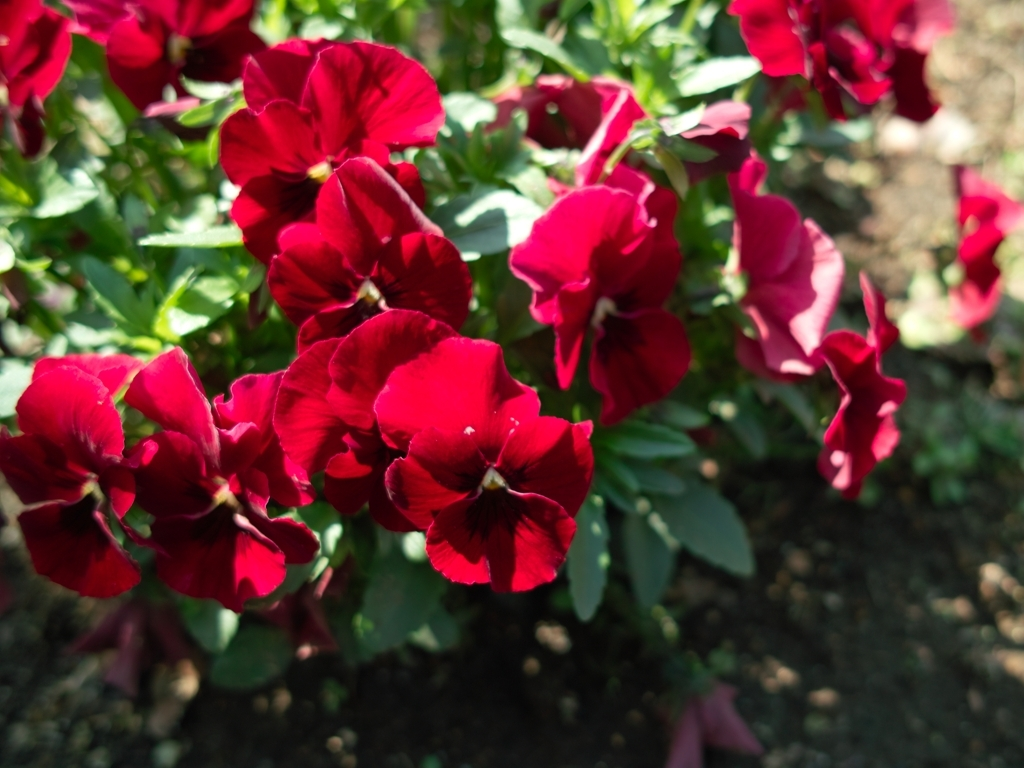Does the image have vibrant colors?
 Yes 